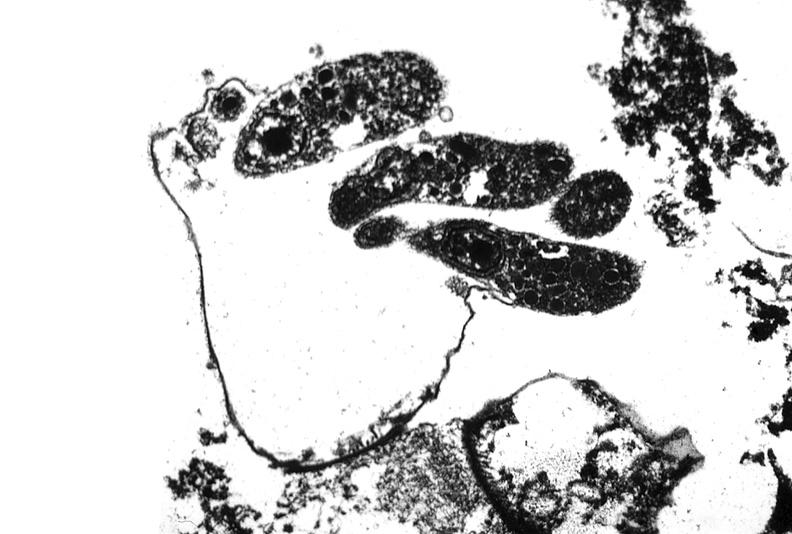does good example of muscle atrophy show colon biopsy, cryptosporidia?
Answer the question using a single word or phrase. No 